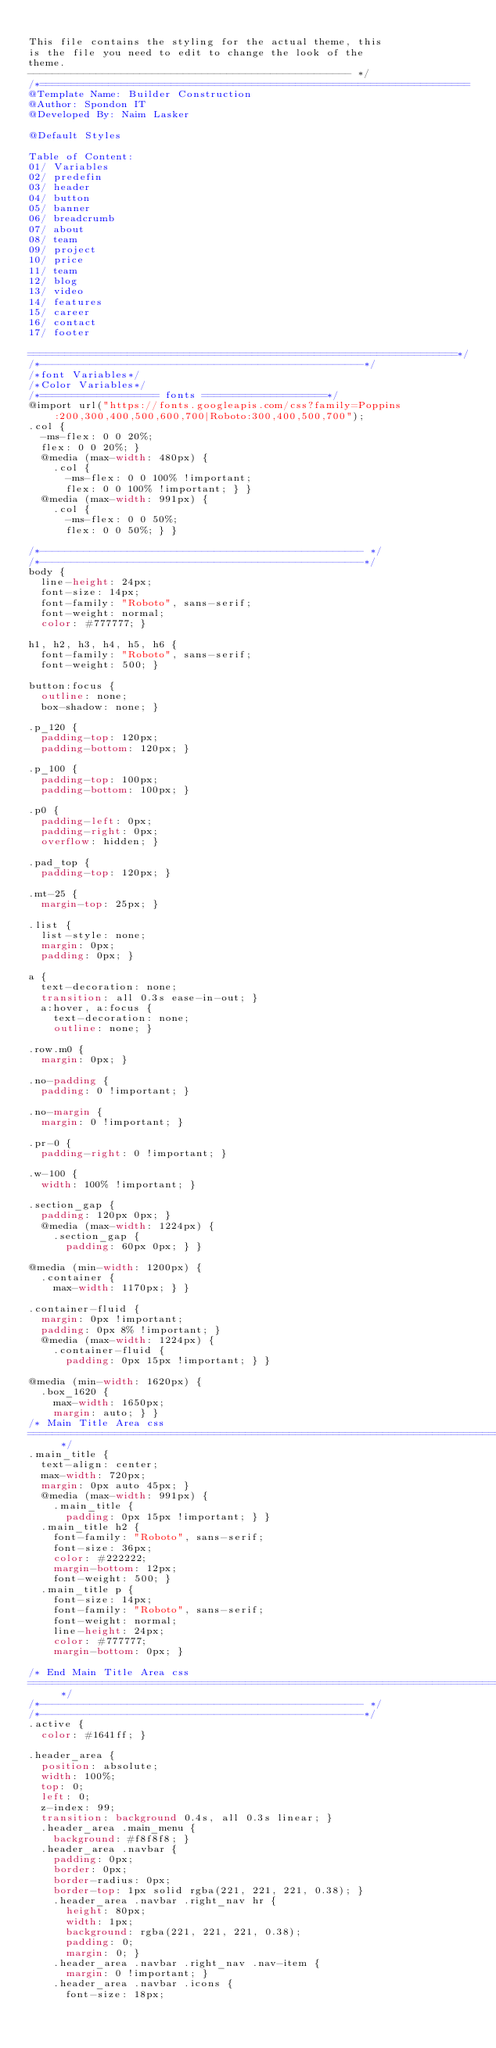Convert code to text. <code><loc_0><loc_0><loc_500><loc_500><_CSS_>
This file contains the styling for the actual theme, this
is the file you need to edit to change the look of the
theme.
---------------------------------------------------- */
/*=====================================================================
@Template Name: Builder Construction 
@Author: Spondon IT
@Developed By: Naim Lasker

@Default Styles

Table of Content:
01/ Variables
02/ predefin
03/ header
04/ button
05/ banner
06/ breadcrumb
07/ about
08/ team
09/ project 
10/ price 
11/ team 
12/ blog 
13/ video  
14/ features  
15/ career  
16/ contact 
17/ footer

=====================================================================*/
/*----------------------------------------------------*/
/*font Variables*/
/*Color Variables*/
/*=================== fonts ====================*/
@import url("https://fonts.googleapis.com/css?family=Poppins:200,300,400,500,600,700|Roboto:300,400,500,700");
.col {
  -ms-flex: 0 0 20%;
  flex: 0 0 20%; }
  @media (max-width: 480px) {
    .col {
      -ms-flex: 0 0 100% !important;
      flex: 0 0 100% !important; } }
  @media (max-width: 991px) {
    .col {
      -ms-flex: 0 0 50%;
      flex: 0 0 50%; } }

/*---------------------------------------------------- */
/*----------------------------------------------------*/
body {
  line-height: 24px;
  font-size: 14px;
  font-family: "Roboto", sans-serif;
  font-weight: normal;
  color: #777777; }

h1, h2, h3, h4, h5, h6 {
  font-family: "Roboto", sans-serif;
  font-weight: 500; }

button:focus {
  outline: none;
  box-shadow: none; }

.p_120 {
  padding-top: 120px;
  padding-bottom: 120px; }

.p_100 {
  padding-top: 100px;
  padding-bottom: 100px; }

.p0 {
  padding-left: 0px;
  padding-right: 0px;
  overflow: hidden; }

.pad_top {
  padding-top: 120px; }

.mt-25 {
  margin-top: 25px; }

.list {
  list-style: none;
  margin: 0px;
  padding: 0px; }

a {
  text-decoration: none;
  transition: all 0.3s ease-in-out; }
  a:hover, a:focus {
    text-decoration: none;
    outline: none; }

.row.m0 {
  margin: 0px; }

.no-padding {
  padding: 0 !important; }

.no-margin {
  margin: 0 !important; }

.pr-0 {
  padding-right: 0 !important; }

.w-100 {
  width: 100% !important; }

.section_gap {
  padding: 120px 0px; }
  @media (max-width: 1224px) {
    .section_gap {
      padding: 60px 0px; } }

@media (min-width: 1200px) {
  .container {
    max-width: 1170px; } }

.container-fluid {
  margin: 0px !important;
  padding: 0px 8% !important; }
  @media (max-width: 1224px) {
    .container-fluid {
      padding: 0px 15px !important; } }

@media (min-width: 1620px) {
  .box_1620 {
    max-width: 1650px;
    margin: auto; } }
/* Main Title Area css
============================================================================================ */
.main_title {
  text-align: center;
  max-width: 720px;
  margin: 0px auto 45px; }
  @media (max-width: 991px) {
    .main_title {
      padding: 0px 15px !important; } }
  .main_title h2 {
    font-family: "Roboto", sans-serif;
    font-size: 36px;
    color: #222222;
    margin-bottom: 12px;
    font-weight: 500; }
  .main_title p {
    font-size: 14px;
    font-family: "Roboto", sans-serif;
    font-weight: normal;
    line-height: 24px;
    color: #777777;
    margin-bottom: 0px; }

/* End Main Title Area css
============================================================================================ */
/*---------------------------------------------------- */
/*----------------------------------------------------*/
.active {
  color: #1641ff; }

.header_area {
  position: absolute;
  width: 100%;
  top: 0;
  left: 0;
  z-index: 99;
  transition: background 0.4s, all 0.3s linear; }
  .header_area .main_menu {
    background: #f8f8f8; }
  .header_area .navbar {
    padding: 0px;
    border: 0px;
    border-radius: 0px;
    border-top: 1px solid rgba(221, 221, 221, 0.38); }
    .header_area .navbar .right_nav hr {
      height: 80px;
      width: 1px;
      background: rgba(221, 221, 221, 0.38);
      padding: 0;
      margin: 0; }
    .header_area .navbar .right_nav .nav-item {
      margin: 0 !important; }
    .header_area .navbar .icons {
      font-size: 18px;</code> 